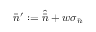<formula> <loc_0><loc_0><loc_500><loc_500>\bar { n } ^ { \prime } \colon = \widehat { \bar { n } } + w \sigma _ { \bar { n } }</formula> 